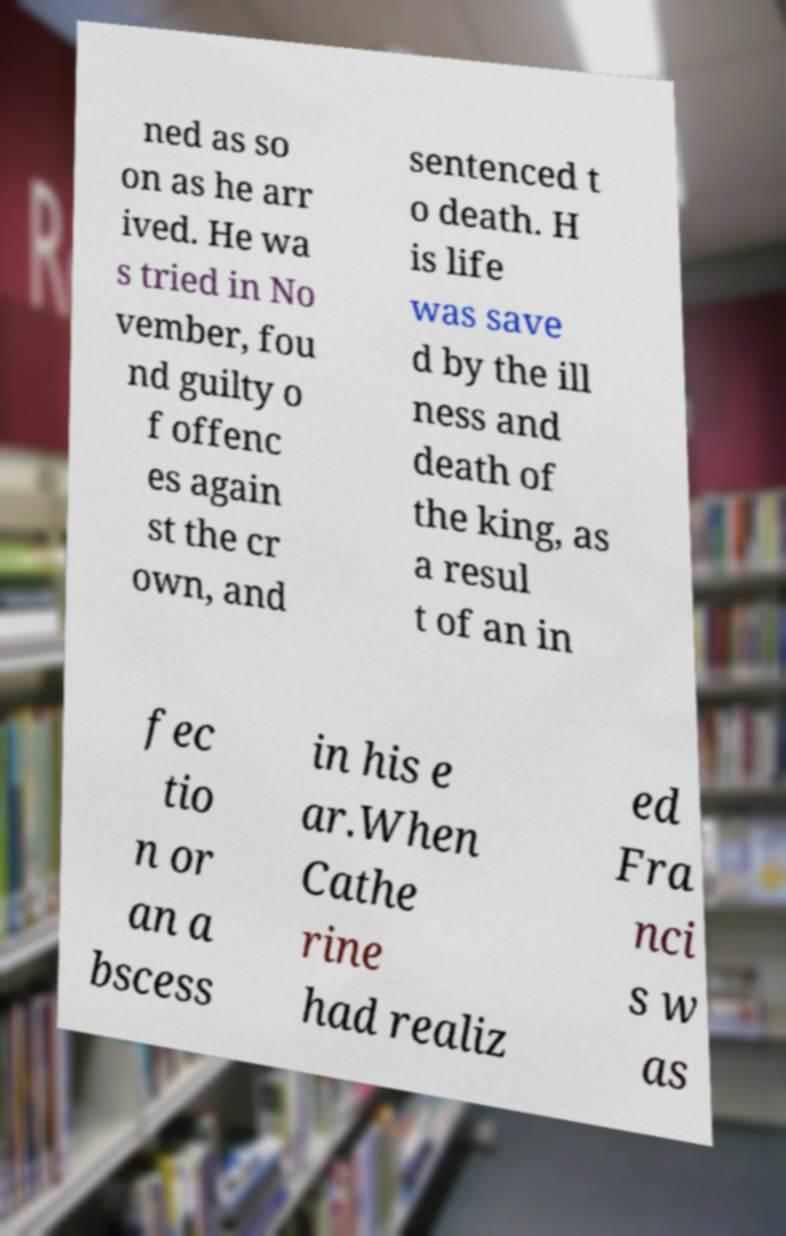Can you accurately transcribe the text from the provided image for me? ned as so on as he arr ived. He wa s tried in No vember, fou nd guilty o f offenc es again st the cr own, and sentenced t o death. H is life was save d by the ill ness and death of the king, as a resul t of an in fec tio n or an a bscess in his e ar.When Cathe rine had realiz ed Fra nci s w as 